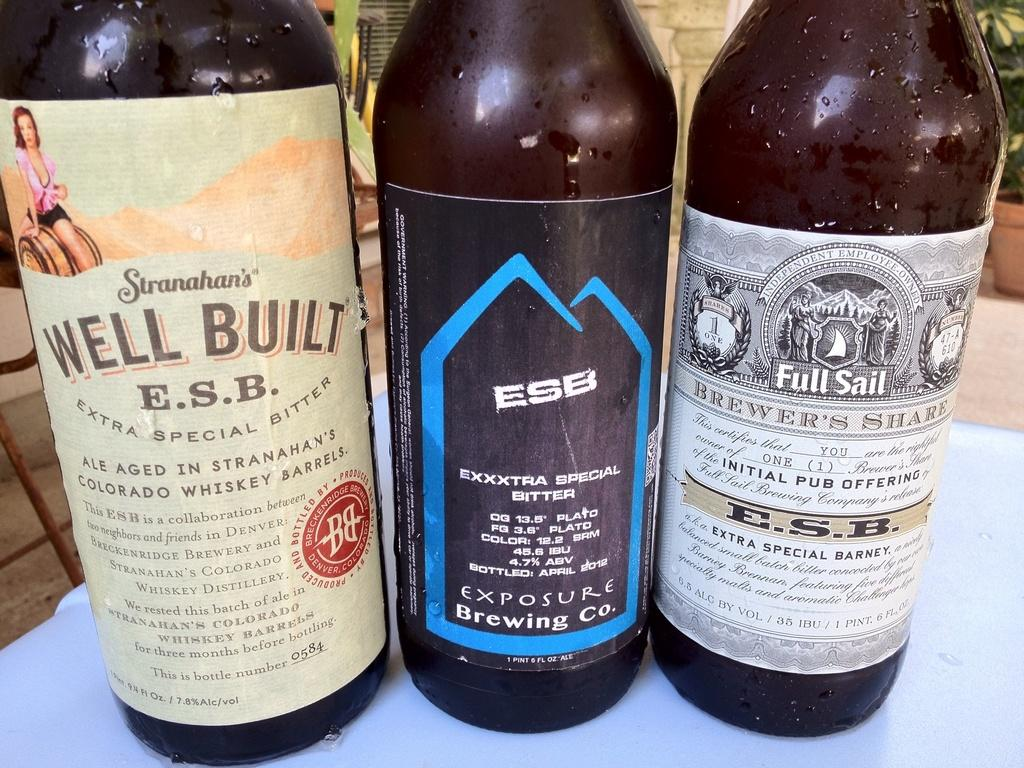<image>
Render a clear and concise summary of the photo. Bottles of whiskey have ESB on the labels. 